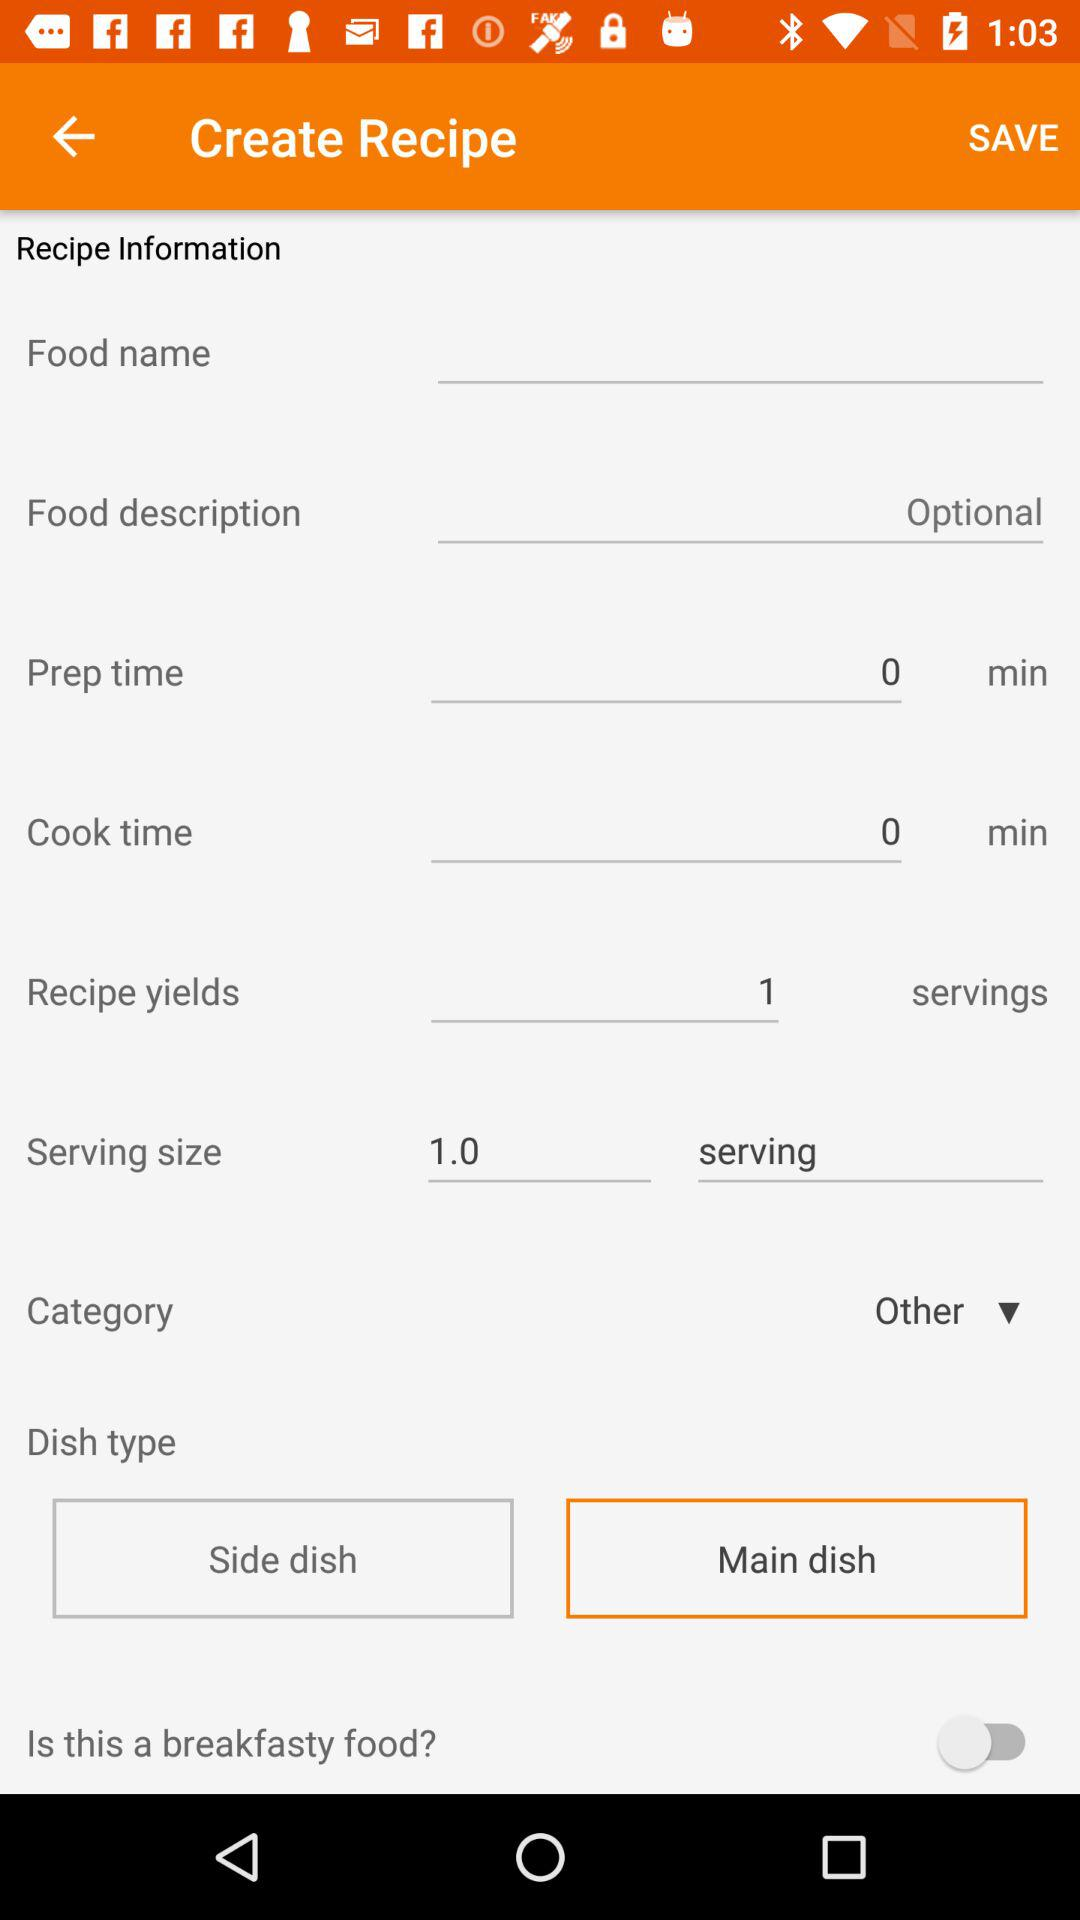Which category is selected? The selected category is "Other". 